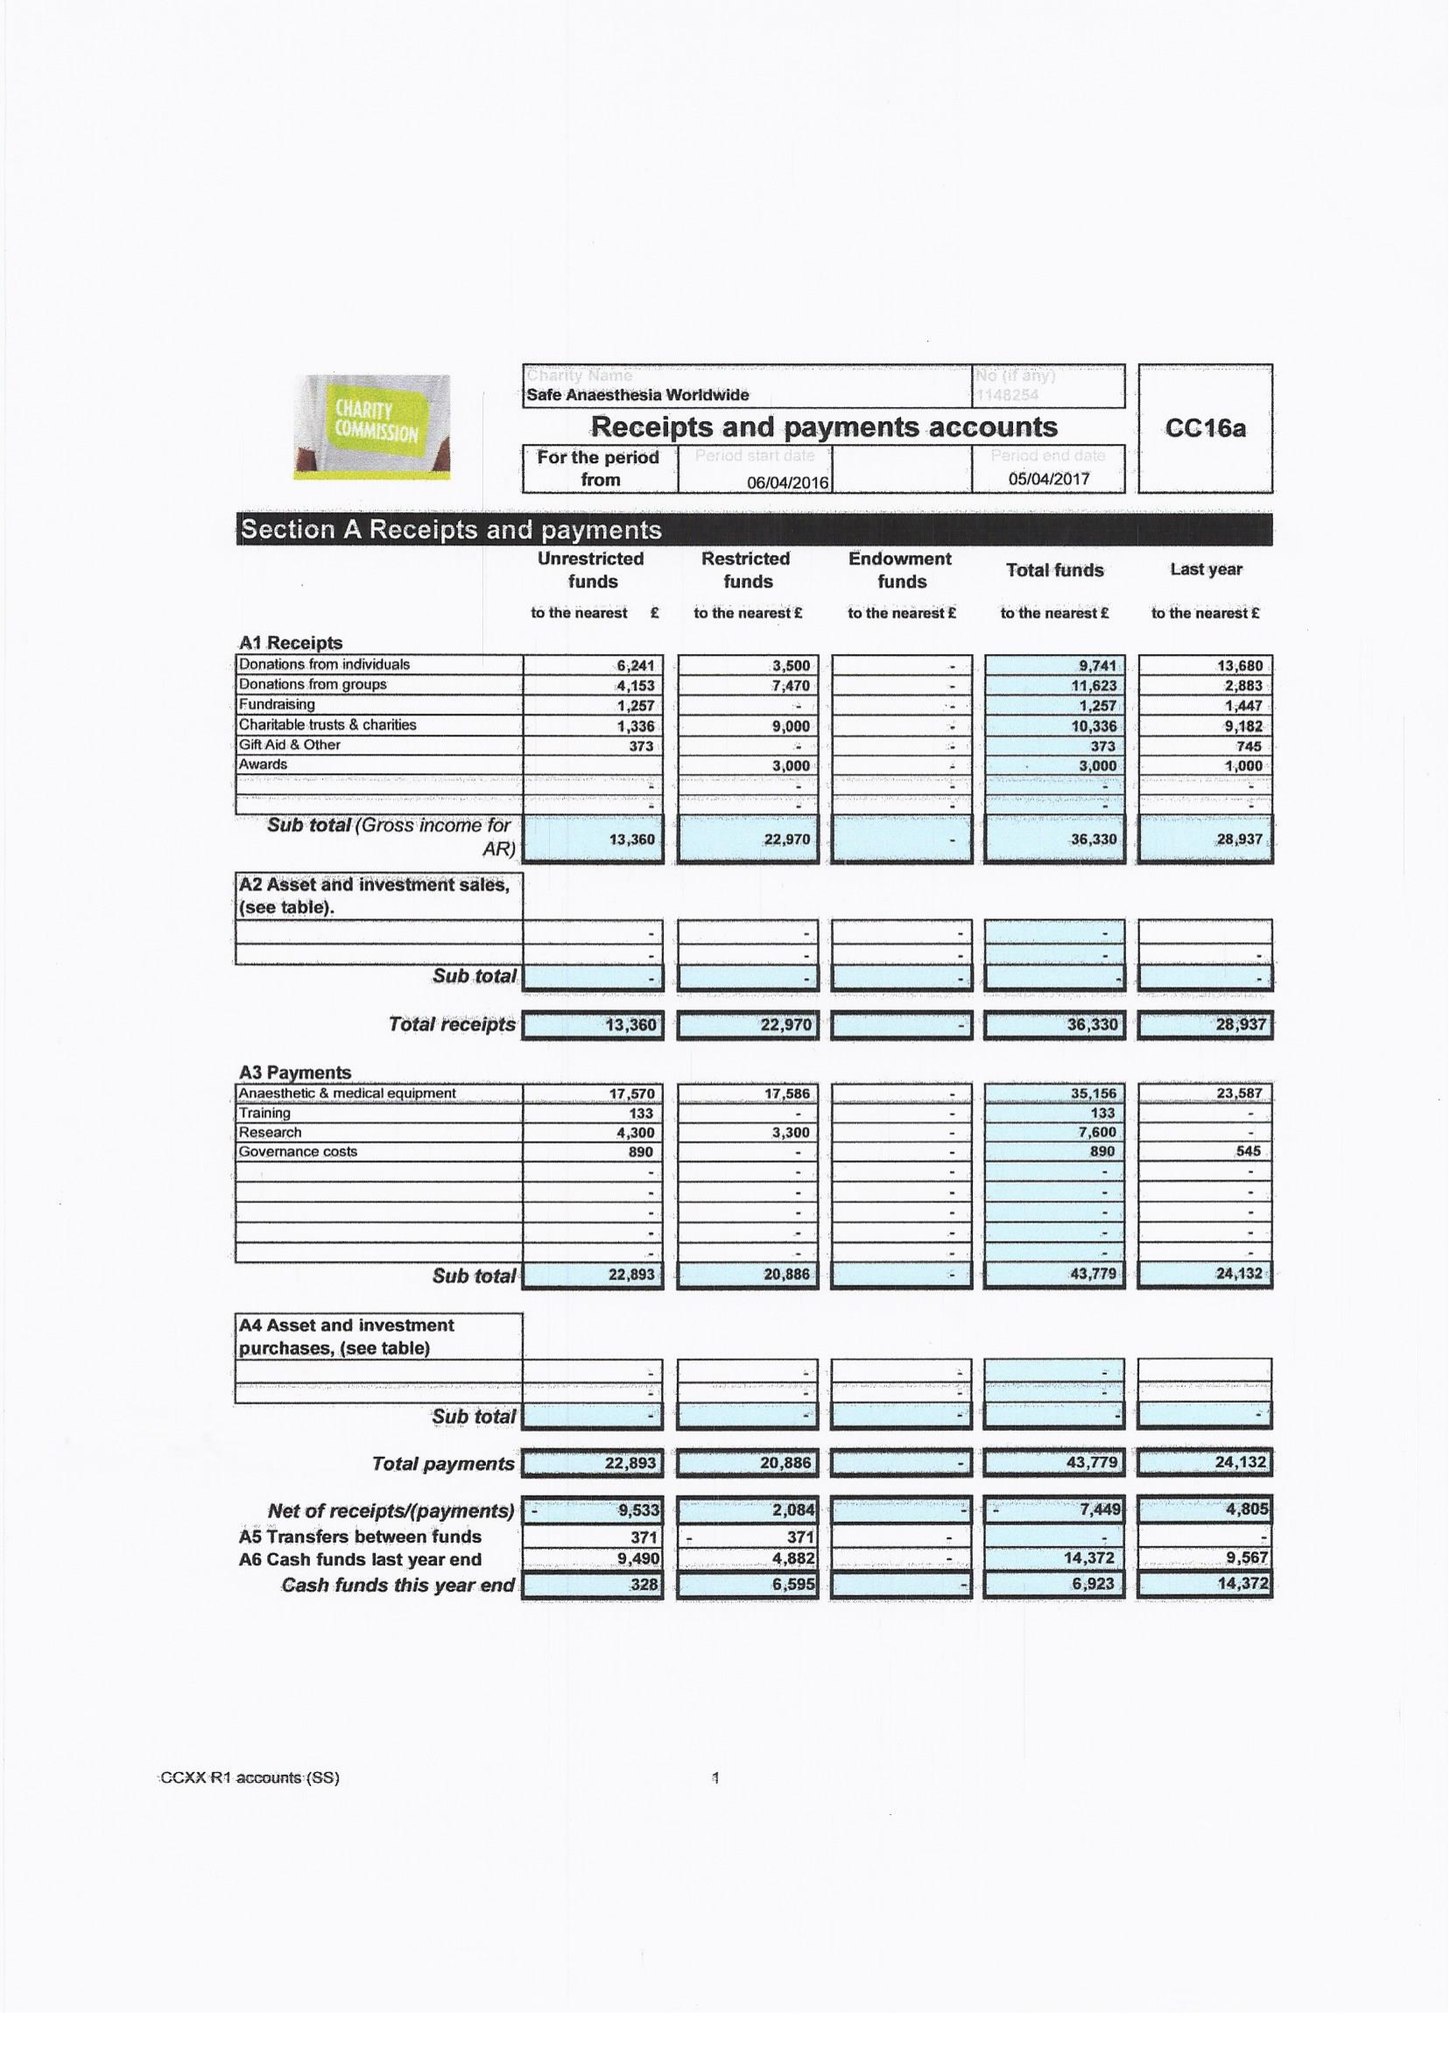What is the value for the income_annually_in_british_pounds?
Answer the question using a single word or phrase. 36330.00 